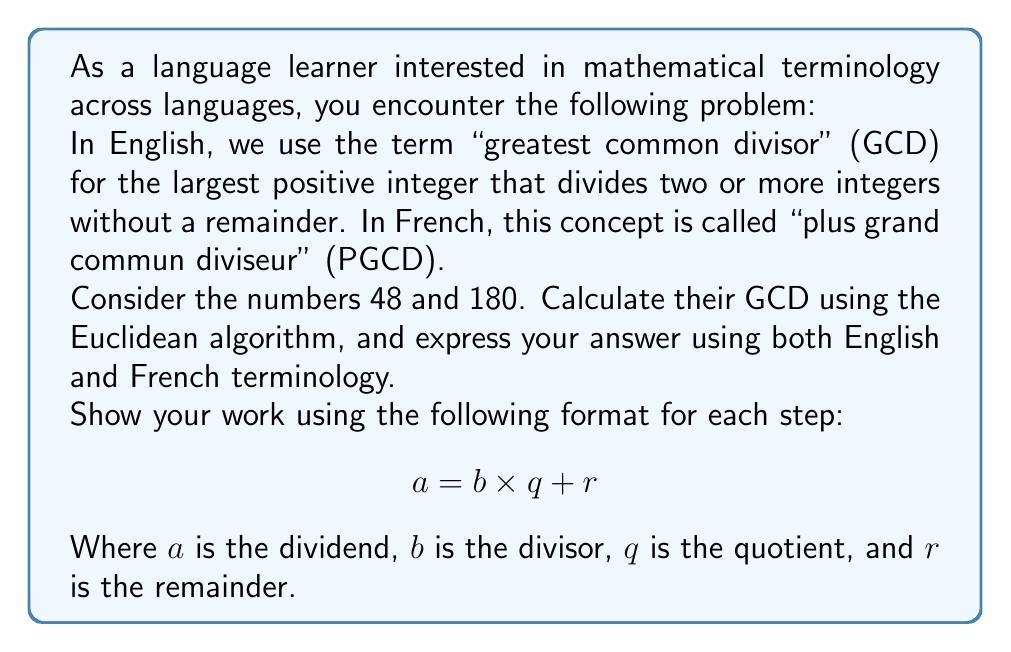Provide a solution to this math problem. Let's apply the Euclidean algorithm to find the GCD of 48 and 180:

Step 1: Divide 180 by 48
$$180 = 48 \times 3 + 36$$

Step 2: Divide 48 by 36
$$48 = 36 \times 1 + 12$$

Step 3: Divide 36 by 12
$$36 = 12 \times 3 + 0$$

The process stops when we get a remainder of 0. The last non-zero remainder is the GCD.

Therefore, the GCD of 48 and 180 is 12.

In English, we would say: The greatest common divisor of 48 and 180 is 12.
In French, we would say: Le plus grand commun diviseur de 48 et 180 est 12.
Answer: GCD = 12; PGCD = 12 